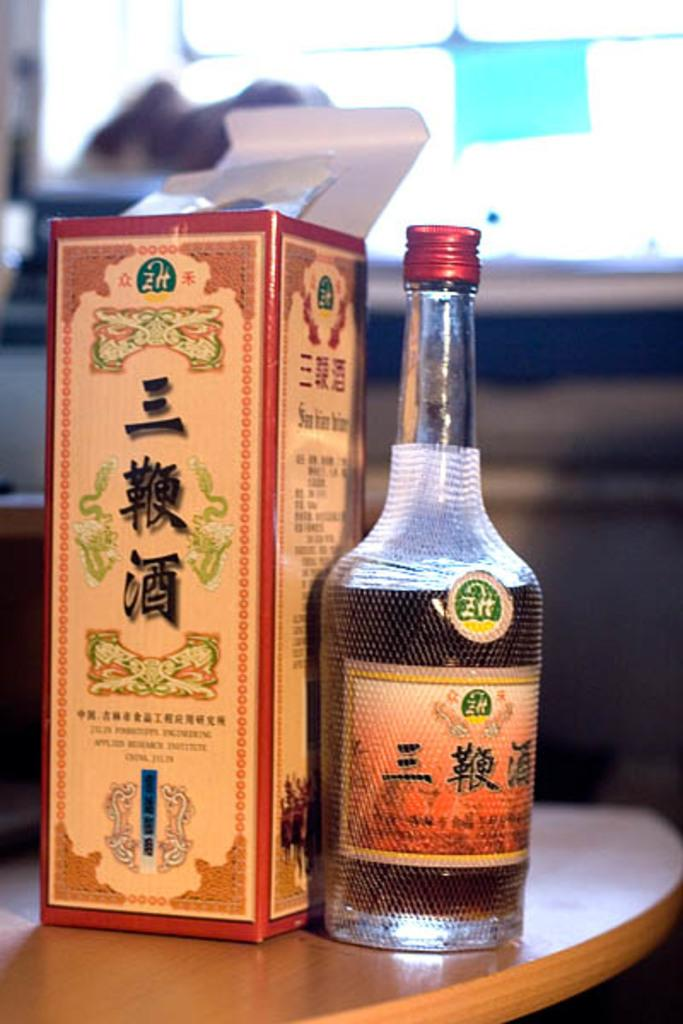<image>
Share a concise interpretation of the image provided. A box from an Asian bottle of alcohol has a word near the bottom that starts with the letter J. 